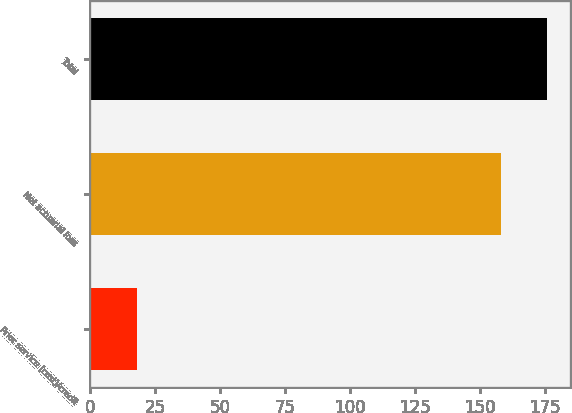Convert chart. <chart><loc_0><loc_0><loc_500><loc_500><bar_chart><fcel>Prior service (cost)/credit<fcel>Net actuarial loss<fcel>Total<nl><fcel>18<fcel>158<fcel>176<nl></chart> 